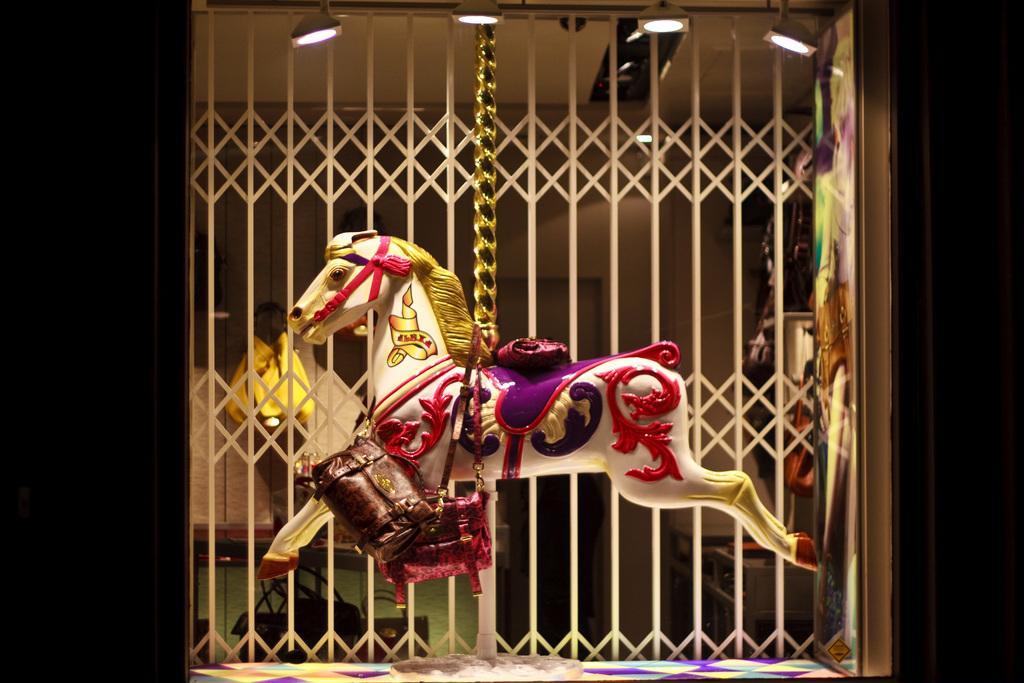Please provide a concise description of this image. In this picture we can see a carousel horse with bags. Behind the carousel horse there is the iron grilles and a board. Behind the iron grilles there are some objects and a wall. At the top there are lights. 